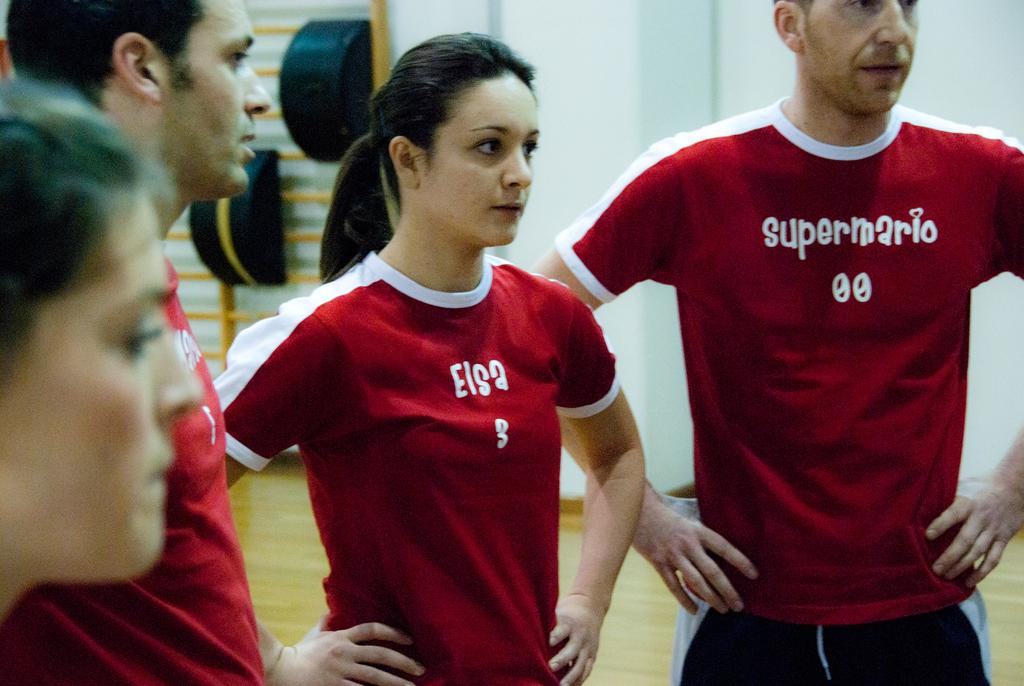Provide a one-sentence caption for the provided image. Two people standing next to one another with a shirt that says "Elsa". 